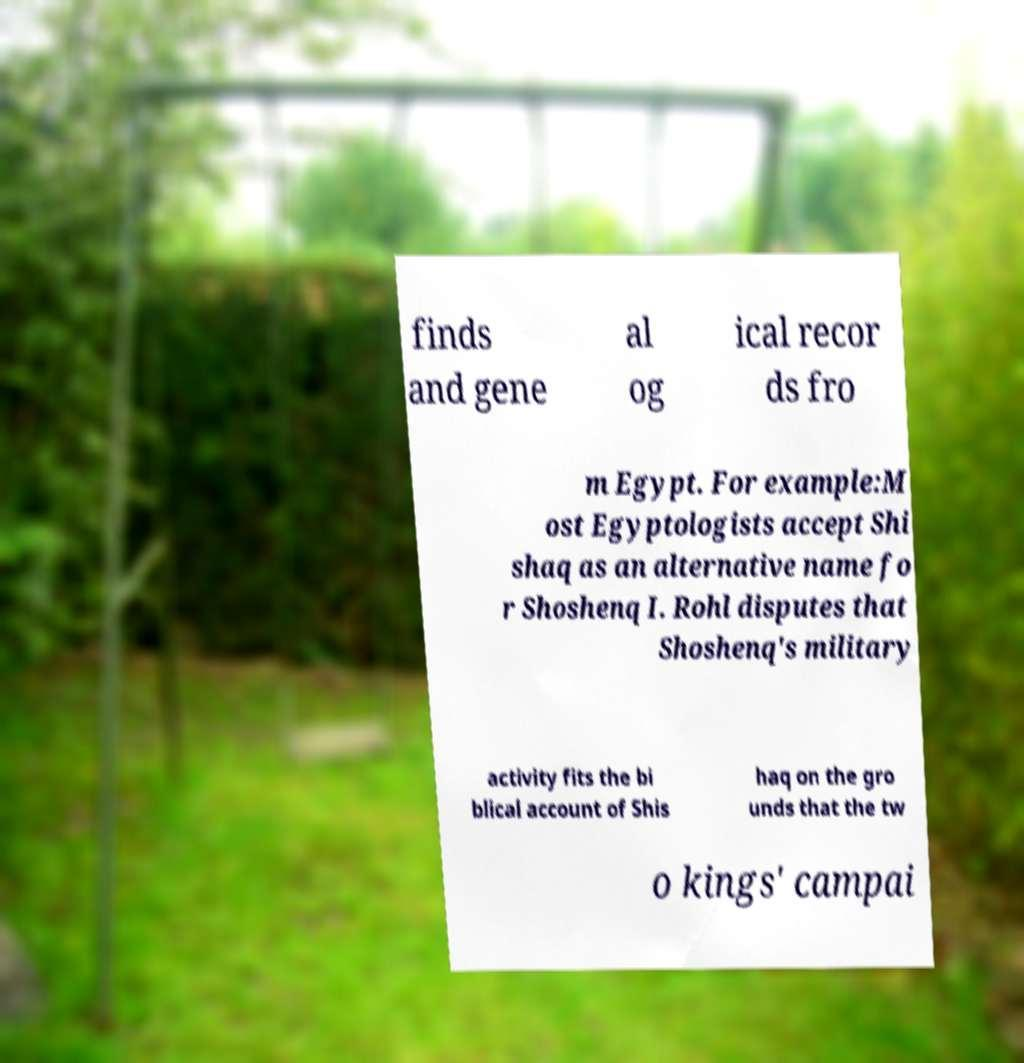Could you assist in decoding the text presented in this image and type it out clearly? finds and gene al og ical recor ds fro m Egypt. For example:M ost Egyptologists accept Shi shaq as an alternative name fo r Shoshenq I. Rohl disputes that Shoshenq's military activity fits the bi blical account of Shis haq on the gro unds that the tw o kings' campai 